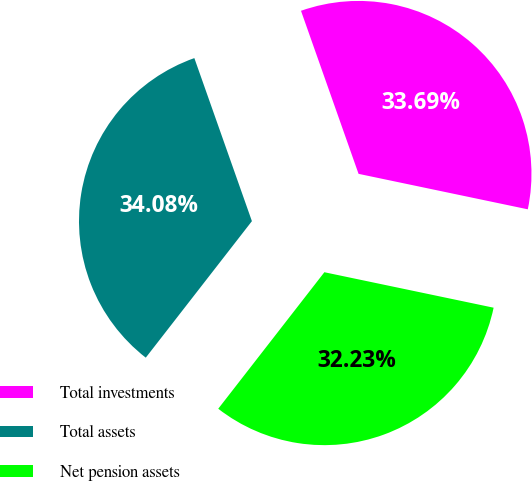Convert chart to OTSL. <chart><loc_0><loc_0><loc_500><loc_500><pie_chart><fcel>Total investments<fcel>Total assets<fcel>Net pension assets<nl><fcel>33.69%<fcel>34.08%<fcel>32.23%<nl></chart> 